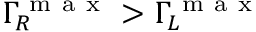<formula> <loc_0><loc_0><loc_500><loc_500>\Gamma _ { R } ^ { m a x } > \Gamma _ { L } ^ { m a x }</formula> 